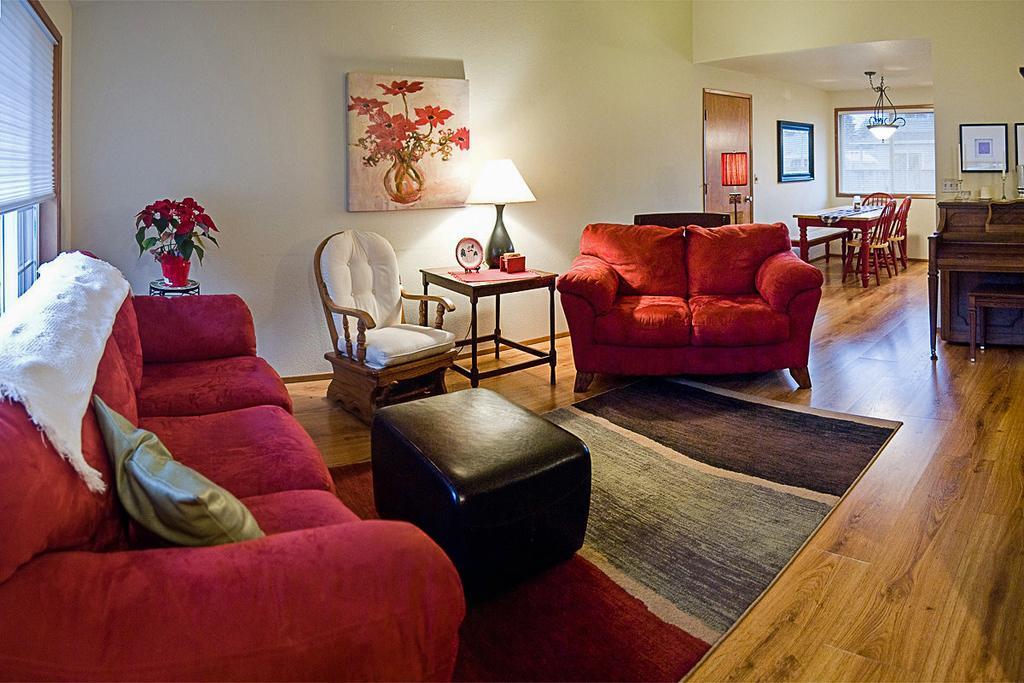Please provide a concise description of this image. In this image we can some chairs and tables placed on the ground. In the center of the image we can see a lamp and some objects placed on a table. On the left side of the image we can see flowers to a plant placed in the pot, we can also see a window blinds. On the right side of the image we can see some candles placed on a piano and some photo frames on the wall. In the background, we can see a window and a door. 